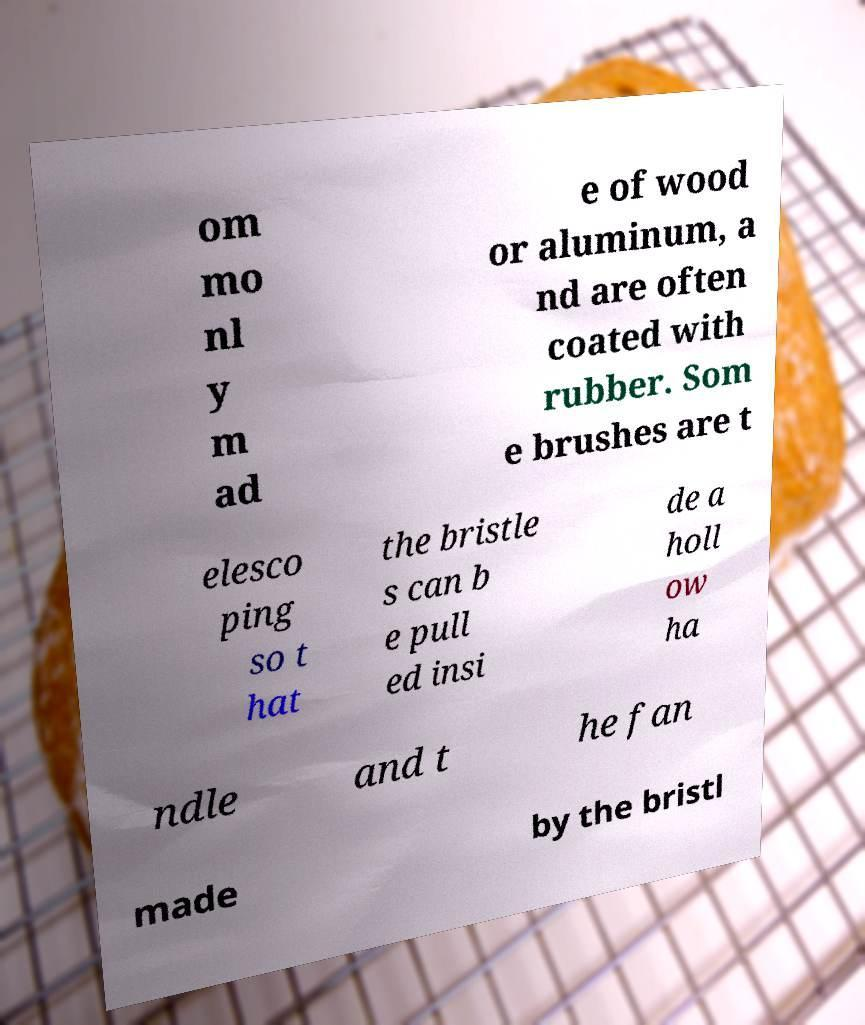Can you accurately transcribe the text from the provided image for me? om mo nl y m ad e of wood or aluminum, a nd are often coated with rubber. Som e brushes are t elesco ping so t hat the bristle s can b e pull ed insi de a holl ow ha ndle and t he fan made by the bristl 